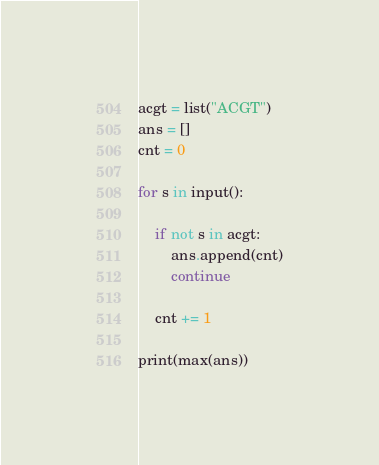Convert code to text. <code><loc_0><loc_0><loc_500><loc_500><_Python_>acgt = list("ACGT")
ans = []
cnt = 0

for s in input():

    if not s in acgt:
        ans.append(cnt)
        continue
    
    cnt += 1

print(max(ans))</code> 